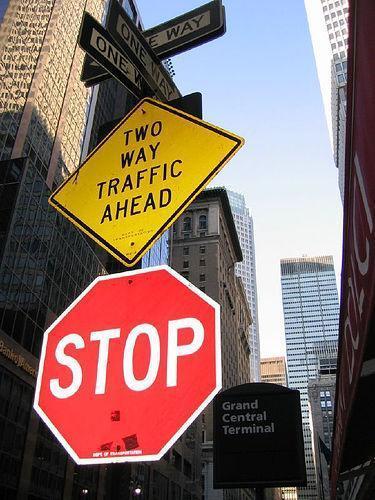How many ways?
Give a very brief answer. 2. How many stop signs are in the photo?
Give a very brief answer. 1. 